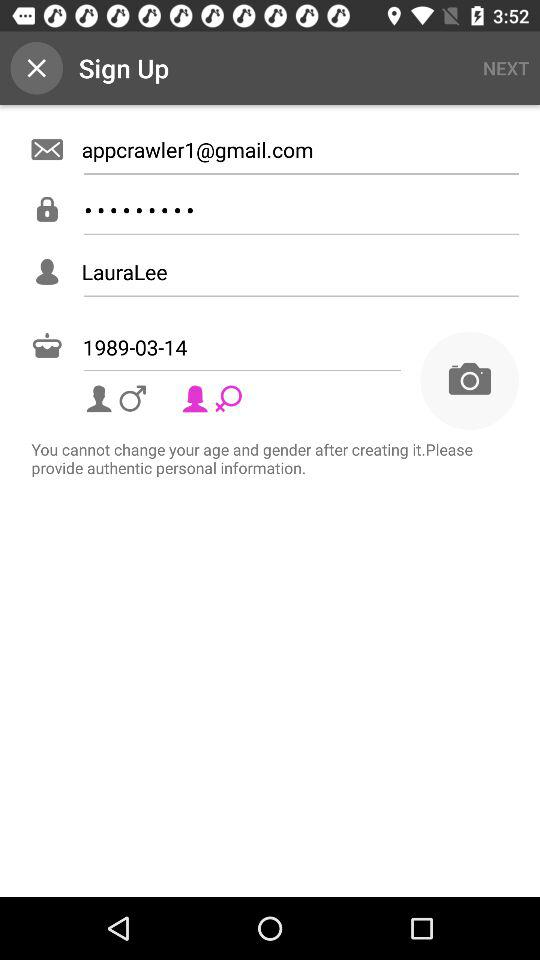Which gender is selected? The selected gender is female. 